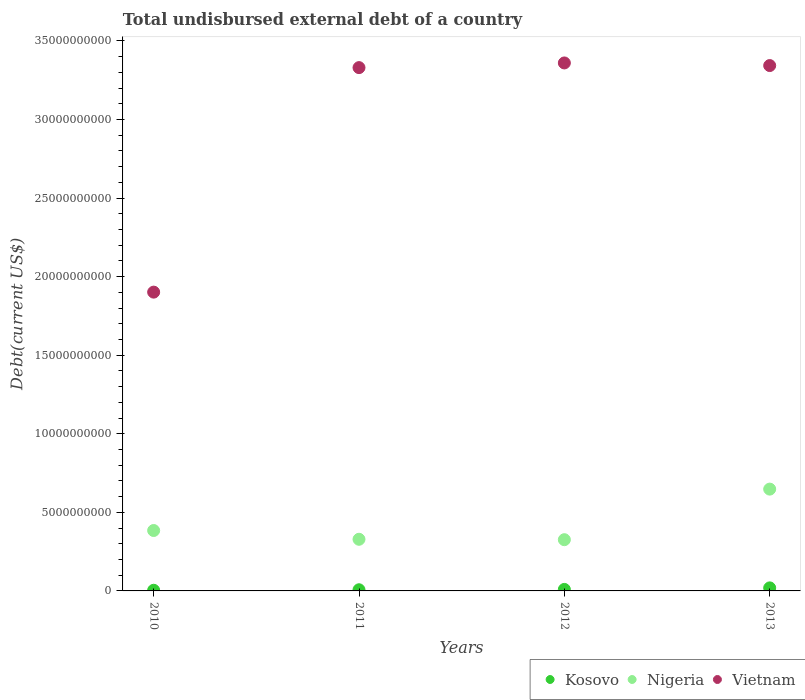How many different coloured dotlines are there?
Offer a very short reply. 3. Is the number of dotlines equal to the number of legend labels?
Offer a very short reply. Yes. What is the total undisbursed external debt in Vietnam in 2011?
Give a very brief answer. 3.33e+1. Across all years, what is the maximum total undisbursed external debt in Kosovo?
Your response must be concise. 1.93e+08. Across all years, what is the minimum total undisbursed external debt in Nigeria?
Provide a succinct answer. 3.26e+09. In which year was the total undisbursed external debt in Kosovo maximum?
Offer a very short reply. 2013. In which year was the total undisbursed external debt in Kosovo minimum?
Offer a very short reply. 2010. What is the total total undisbursed external debt in Vietnam in the graph?
Ensure brevity in your answer.  1.19e+11. What is the difference between the total undisbursed external debt in Kosovo in 2011 and that in 2013?
Ensure brevity in your answer.  -1.20e+08. What is the difference between the total undisbursed external debt in Vietnam in 2011 and the total undisbursed external debt in Nigeria in 2012?
Keep it short and to the point. 3.00e+1. What is the average total undisbursed external debt in Kosovo per year?
Provide a short and direct response. 1.01e+08. In the year 2012, what is the difference between the total undisbursed external debt in Kosovo and total undisbursed external debt in Vietnam?
Offer a terse response. -3.35e+1. In how many years, is the total undisbursed external debt in Nigeria greater than 17000000000 US$?
Offer a very short reply. 0. What is the ratio of the total undisbursed external debt in Kosovo in 2011 to that in 2012?
Your response must be concise. 0.77. Is the total undisbursed external debt in Kosovo in 2010 less than that in 2013?
Ensure brevity in your answer.  Yes. What is the difference between the highest and the second highest total undisbursed external debt in Vietnam?
Make the answer very short. 1.67e+08. What is the difference between the highest and the lowest total undisbursed external debt in Vietnam?
Your answer should be very brief. 1.46e+1. Is the total undisbursed external debt in Nigeria strictly less than the total undisbursed external debt in Kosovo over the years?
Your answer should be very brief. No. How many dotlines are there?
Ensure brevity in your answer.  3. Are the values on the major ticks of Y-axis written in scientific E-notation?
Offer a very short reply. No. Does the graph contain any zero values?
Ensure brevity in your answer.  No. Where does the legend appear in the graph?
Provide a short and direct response. Bottom right. How are the legend labels stacked?
Your answer should be very brief. Horizontal. What is the title of the graph?
Provide a short and direct response. Total undisbursed external debt of a country. What is the label or title of the Y-axis?
Ensure brevity in your answer.  Debt(current US$). What is the Debt(current US$) in Kosovo in 2010?
Make the answer very short. 4.18e+07. What is the Debt(current US$) in Nigeria in 2010?
Your answer should be very brief. 3.84e+09. What is the Debt(current US$) of Vietnam in 2010?
Make the answer very short. 1.90e+1. What is the Debt(current US$) of Kosovo in 2011?
Provide a succinct answer. 7.36e+07. What is the Debt(current US$) of Nigeria in 2011?
Offer a terse response. 3.29e+09. What is the Debt(current US$) in Vietnam in 2011?
Your response must be concise. 3.33e+1. What is the Debt(current US$) in Kosovo in 2012?
Make the answer very short. 9.60e+07. What is the Debt(current US$) of Nigeria in 2012?
Make the answer very short. 3.26e+09. What is the Debt(current US$) of Vietnam in 2012?
Give a very brief answer. 3.36e+1. What is the Debt(current US$) of Kosovo in 2013?
Keep it short and to the point. 1.93e+08. What is the Debt(current US$) of Nigeria in 2013?
Your answer should be compact. 6.48e+09. What is the Debt(current US$) of Vietnam in 2013?
Your answer should be compact. 3.34e+1. Across all years, what is the maximum Debt(current US$) in Kosovo?
Offer a terse response. 1.93e+08. Across all years, what is the maximum Debt(current US$) in Nigeria?
Provide a short and direct response. 6.48e+09. Across all years, what is the maximum Debt(current US$) of Vietnam?
Provide a succinct answer. 3.36e+1. Across all years, what is the minimum Debt(current US$) of Kosovo?
Provide a short and direct response. 4.18e+07. Across all years, what is the minimum Debt(current US$) in Nigeria?
Keep it short and to the point. 3.26e+09. Across all years, what is the minimum Debt(current US$) of Vietnam?
Give a very brief answer. 1.90e+1. What is the total Debt(current US$) of Kosovo in the graph?
Your response must be concise. 4.05e+08. What is the total Debt(current US$) in Nigeria in the graph?
Give a very brief answer. 1.69e+1. What is the total Debt(current US$) of Vietnam in the graph?
Give a very brief answer. 1.19e+11. What is the difference between the Debt(current US$) of Kosovo in 2010 and that in 2011?
Provide a succinct answer. -3.18e+07. What is the difference between the Debt(current US$) in Nigeria in 2010 and that in 2011?
Offer a very short reply. 5.58e+08. What is the difference between the Debt(current US$) in Vietnam in 2010 and that in 2011?
Your answer should be very brief. -1.43e+1. What is the difference between the Debt(current US$) of Kosovo in 2010 and that in 2012?
Ensure brevity in your answer.  -5.42e+07. What is the difference between the Debt(current US$) in Nigeria in 2010 and that in 2012?
Offer a terse response. 5.84e+08. What is the difference between the Debt(current US$) in Vietnam in 2010 and that in 2012?
Keep it short and to the point. -1.46e+1. What is the difference between the Debt(current US$) in Kosovo in 2010 and that in 2013?
Offer a terse response. -1.51e+08. What is the difference between the Debt(current US$) in Nigeria in 2010 and that in 2013?
Your answer should be compact. -2.63e+09. What is the difference between the Debt(current US$) in Vietnam in 2010 and that in 2013?
Your answer should be very brief. -1.44e+1. What is the difference between the Debt(current US$) in Kosovo in 2011 and that in 2012?
Offer a very short reply. -2.24e+07. What is the difference between the Debt(current US$) in Nigeria in 2011 and that in 2012?
Ensure brevity in your answer.  2.67e+07. What is the difference between the Debt(current US$) of Vietnam in 2011 and that in 2012?
Your response must be concise. -2.98e+08. What is the difference between the Debt(current US$) of Kosovo in 2011 and that in 2013?
Your answer should be compact. -1.20e+08. What is the difference between the Debt(current US$) of Nigeria in 2011 and that in 2013?
Provide a succinct answer. -3.19e+09. What is the difference between the Debt(current US$) in Vietnam in 2011 and that in 2013?
Make the answer very short. -1.31e+08. What is the difference between the Debt(current US$) in Kosovo in 2012 and that in 2013?
Provide a succinct answer. -9.72e+07. What is the difference between the Debt(current US$) in Nigeria in 2012 and that in 2013?
Your answer should be compact. -3.22e+09. What is the difference between the Debt(current US$) in Vietnam in 2012 and that in 2013?
Give a very brief answer. 1.67e+08. What is the difference between the Debt(current US$) in Kosovo in 2010 and the Debt(current US$) in Nigeria in 2011?
Provide a short and direct response. -3.24e+09. What is the difference between the Debt(current US$) in Kosovo in 2010 and the Debt(current US$) in Vietnam in 2011?
Your answer should be compact. -3.33e+1. What is the difference between the Debt(current US$) of Nigeria in 2010 and the Debt(current US$) of Vietnam in 2011?
Provide a succinct answer. -2.95e+1. What is the difference between the Debt(current US$) of Kosovo in 2010 and the Debt(current US$) of Nigeria in 2012?
Offer a terse response. -3.22e+09. What is the difference between the Debt(current US$) in Kosovo in 2010 and the Debt(current US$) in Vietnam in 2012?
Your answer should be compact. -3.36e+1. What is the difference between the Debt(current US$) of Nigeria in 2010 and the Debt(current US$) of Vietnam in 2012?
Keep it short and to the point. -2.98e+1. What is the difference between the Debt(current US$) in Kosovo in 2010 and the Debt(current US$) in Nigeria in 2013?
Your answer should be very brief. -6.44e+09. What is the difference between the Debt(current US$) of Kosovo in 2010 and the Debt(current US$) of Vietnam in 2013?
Offer a terse response. -3.34e+1. What is the difference between the Debt(current US$) of Nigeria in 2010 and the Debt(current US$) of Vietnam in 2013?
Offer a terse response. -2.96e+1. What is the difference between the Debt(current US$) of Kosovo in 2011 and the Debt(current US$) of Nigeria in 2012?
Offer a terse response. -3.19e+09. What is the difference between the Debt(current US$) of Kosovo in 2011 and the Debt(current US$) of Vietnam in 2012?
Ensure brevity in your answer.  -3.35e+1. What is the difference between the Debt(current US$) in Nigeria in 2011 and the Debt(current US$) in Vietnam in 2012?
Provide a short and direct response. -3.03e+1. What is the difference between the Debt(current US$) in Kosovo in 2011 and the Debt(current US$) in Nigeria in 2013?
Make the answer very short. -6.40e+09. What is the difference between the Debt(current US$) in Kosovo in 2011 and the Debt(current US$) in Vietnam in 2013?
Make the answer very short. -3.34e+1. What is the difference between the Debt(current US$) of Nigeria in 2011 and the Debt(current US$) of Vietnam in 2013?
Provide a short and direct response. -3.01e+1. What is the difference between the Debt(current US$) in Kosovo in 2012 and the Debt(current US$) in Nigeria in 2013?
Your response must be concise. -6.38e+09. What is the difference between the Debt(current US$) in Kosovo in 2012 and the Debt(current US$) in Vietnam in 2013?
Keep it short and to the point. -3.33e+1. What is the difference between the Debt(current US$) in Nigeria in 2012 and the Debt(current US$) in Vietnam in 2013?
Make the answer very short. -3.02e+1. What is the average Debt(current US$) of Kosovo per year?
Your response must be concise. 1.01e+08. What is the average Debt(current US$) of Nigeria per year?
Your answer should be compact. 4.22e+09. What is the average Debt(current US$) of Vietnam per year?
Your response must be concise. 2.98e+1. In the year 2010, what is the difference between the Debt(current US$) in Kosovo and Debt(current US$) in Nigeria?
Ensure brevity in your answer.  -3.80e+09. In the year 2010, what is the difference between the Debt(current US$) of Kosovo and Debt(current US$) of Vietnam?
Ensure brevity in your answer.  -1.90e+1. In the year 2010, what is the difference between the Debt(current US$) in Nigeria and Debt(current US$) in Vietnam?
Your response must be concise. -1.52e+1. In the year 2011, what is the difference between the Debt(current US$) in Kosovo and Debt(current US$) in Nigeria?
Give a very brief answer. -3.21e+09. In the year 2011, what is the difference between the Debt(current US$) of Kosovo and Debt(current US$) of Vietnam?
Keep it short and to the point. -3.32e+1. In the year 2011, what is the difference between the Debt(current US$) in Nigeria and Debt(current US$) in Vietnam?
Your response must be concise. -3.00e+1. In the year 2012, what is the difference between the Debt(current US$) of Kosovo and Debt(current US$) of Nigeria?
Offer a very short reply. -3.16e+09. In the year 2012, what is the difference between the Debt(current US$) of Kosovo and Debt(current US$) of Vietnam?
Your answer should be very brief. -3.35e+1. In the year 2012, what is the difference between the Debt(current US$) in Nigeria and Debt(current US$) in Vietnam?
Make the answer very short. -3.03e+1. In the year 2013, what is the difference between the Debt(current US$) in Kosovo and Debt(current US$) in Nigeria?
Offer a very short reply. -6.28e+09. In the year 2013, what is the difference between the Debt(current US$) of Kosovo and Debt(current US$) of Vietnam?
Give a very brief answer. -3.32e+1. In the year 2013, what is the difference between the Debt(current US$) in Nigeria and Debt(current US$) in Vietnam?
Provide a short and direct response. -2.70e+1. What is the ratio of the Debt(current US$) in Kosovo in 2010 to that in 2011?
Provide a succinct answer. 0.57. What is the ratio of the Debt(current US$) of Nigeria in 2010 to that in 2011?
Provide a succinct answer. 1.17. What is the ratio of the Debt(current US$) in Vietnam in 2010 to that in 2011?
Give a very brief answer. 0.57. What is the ratio of the Debt(current US$) of Kosovo in 2010 to that in 2012?
Provide a short and direct response. 0.44. What is the ratio of the Debt(current US$) of Nigeria in 2010 to that in 2012?
Your answer should be compact. 1.18. What is the ratio of the Debt(current US$) in Vietnam in 2010 to that in 2012?
Your answer should be compact. 0.57. What is the ratio of the Debt(current US$) of Kosovo in 2010 to that in 2013?
Provide a succinct answer. 0.22. What is the ratio of the Debt(current US$) of Nigeria in 2010 to that in 2013?
Give a very brief answer. 0.59. What is the ratio of the Debt(current US$) in Vietnam in 2010 to that in 2013?
Provide a short and direct response. 0.57. What is the ratio of the Debt(current US$) of Kosovo in 2011 to that in 2012?
Your answer should be compact. 0.77. What is the ratio of the Debt(current US$) of Nigeria in 2011 to that in 2012?
Give a very brief answer. 1.01. What is the ratio of the Debt(current US$) in Vietnam in 2011 to that in 2012?
Make the answer very short. 0.99. What is the ratio of the Debt(current US$) in Kosovo in 2011 to that in 2013?
Offer a very short reply. 0.38. What is the ratio of the Debt(current US$) of Nigeria in 2011 to that in 2013?
Provide a succinct answer. 0.51. What is the ratio of the Debt(current US$) in Kosovo in 2012 to that in 2013?
Provide a succinct answer. 0.5. What is the ratio of the Debt(current US$) of Nigeria in 2012 to that in 2013?
Your answer should be very brief. 0.5. What is the difference between the highest and the second highest Debt(current US$) of Kosovo?
Offer a very short reply. 9.72e+07. What is the difference between the highest and the second highest Debt(current US$) of Nigeria?
Ensure brevity in your answer.  2.63e+09. What is the difference between the highest and the second highest Debt(current US$) of Vietnam?
Your answer should be compact. 1.67e+08. What is the difference between the highest and the lowest Debt(current US$) of Kosovo?
Your answer should be compact. 1.51e+08. What is the difference between the highest and the lowest Debt(current US$) in Nigeria?
Keep it short and to the point. 3.22e+09. What is the difference between the highest and the lowest Debt(current US$) of Vietnam?
Offer a very short reply. 1.46e+1. 